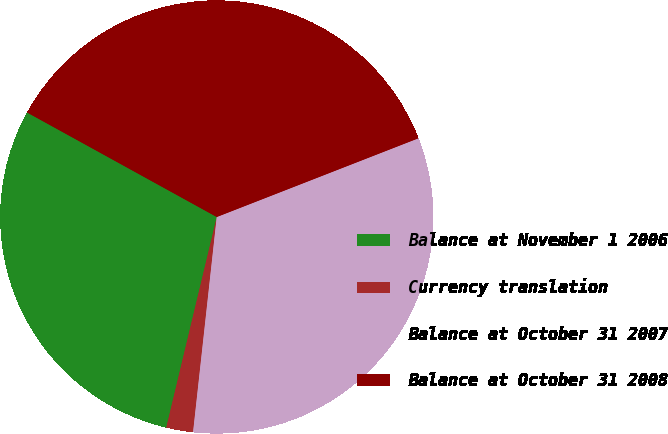Convert chart to OTSL. <chart><loc_0><loc_0><loc_500><loc_500><pie_chart><fcel>Balance at November 1 2006<fcel>Currency translation<fcel>Balance at October 31 2007<fcel>Balance at October 31 2008<nl><fcel>29.27%<fcel>2.0%<fcel>32.67%<fcel>36.06%<nl></chart> 